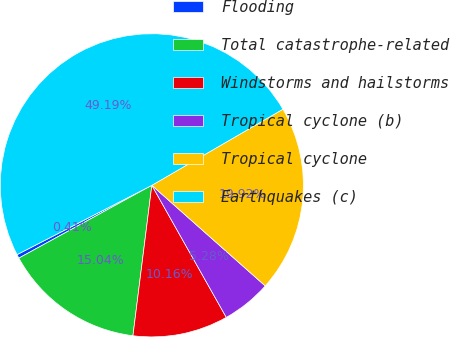<chart> <loc_0><loc_0><loc_500><loc_500><pie_chart><fcel>Flooding<fcel>Total catastrophe-related<fcel>Windstorms and hailstorms<fcel>Tropical cyclone (b)<fcel>Tropical cyclone<fcel>Earthquakes (c)<nl><fcel>0.41%<fcel>15.04%<fcel>10.16%<fcel>5.28%<fcel>19.92%<fcel>49.19%<nl></chart> 